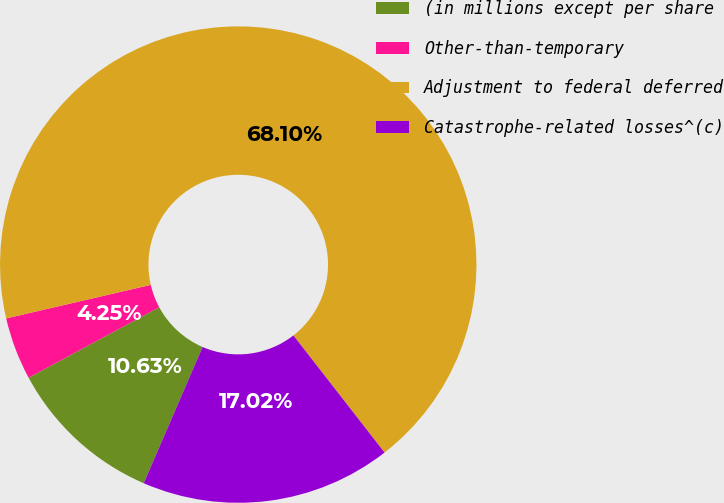Convert chart to OTSL. <chart><loc_0><loc_0><loc_500><loc_500><pie_chart><fcel>(in millions except per share<fcel>Other-than-temporary<fcel>Adjustment to federal deferred<fcel>Catastrophe-related losses^(c)<nl><fcel>10.63%<fcel>4.25%<fcel>68.1%<fcel>17.02%<nl></chart> 